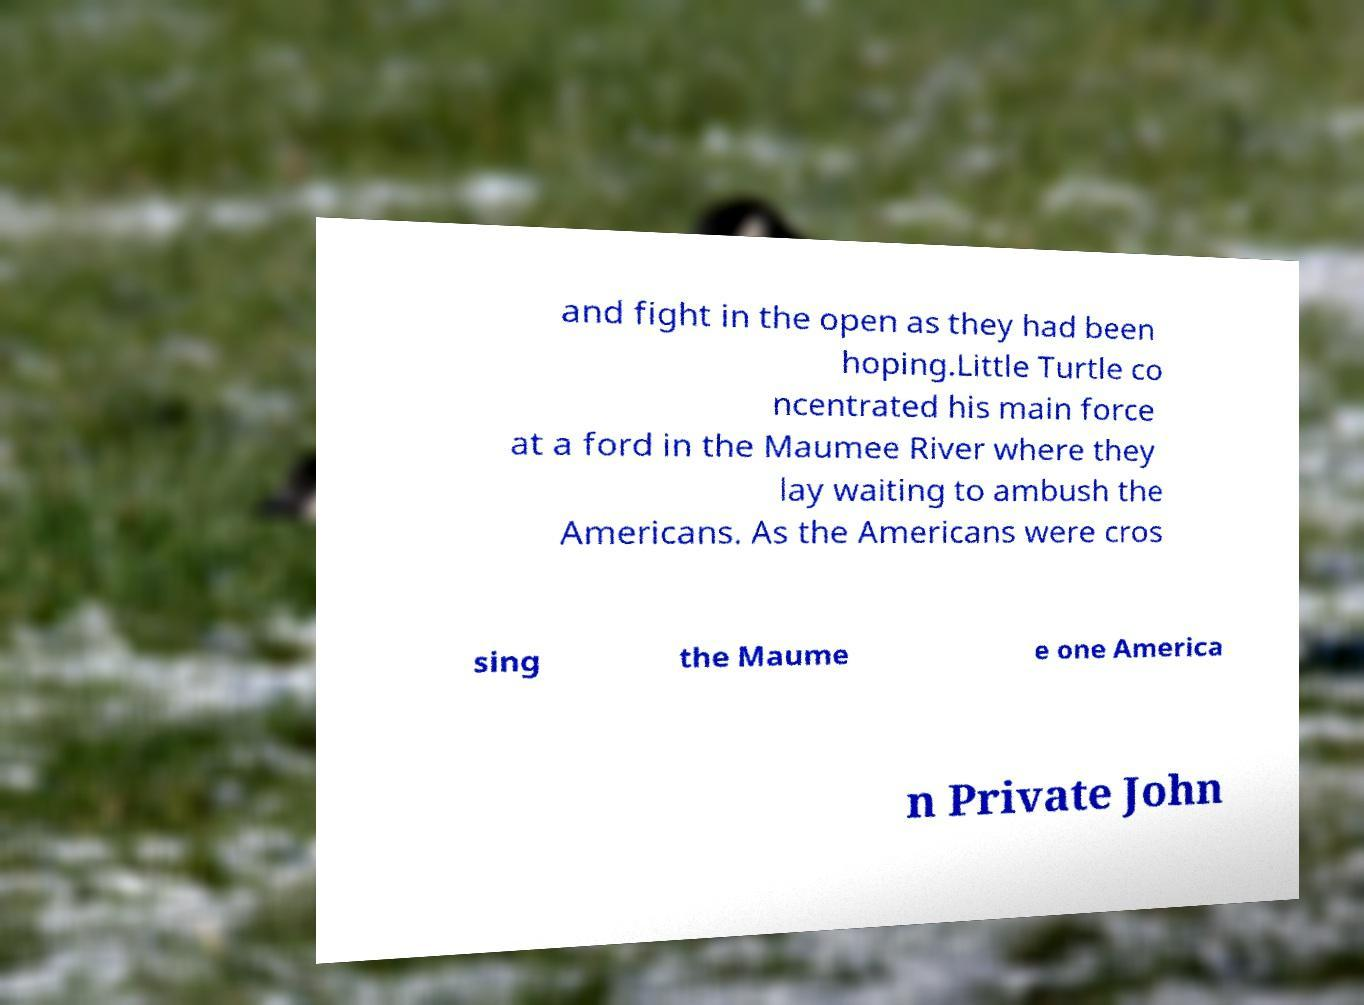Please read and relay the text visible in this image. What does it say? and fight in the open as they had been hoping.Little Turtle co ncentrated his main force at a ford in the Maumee River where they lay waiting to ambush the Americans. As the Americans were cros sing the Maume e one America n Private John 